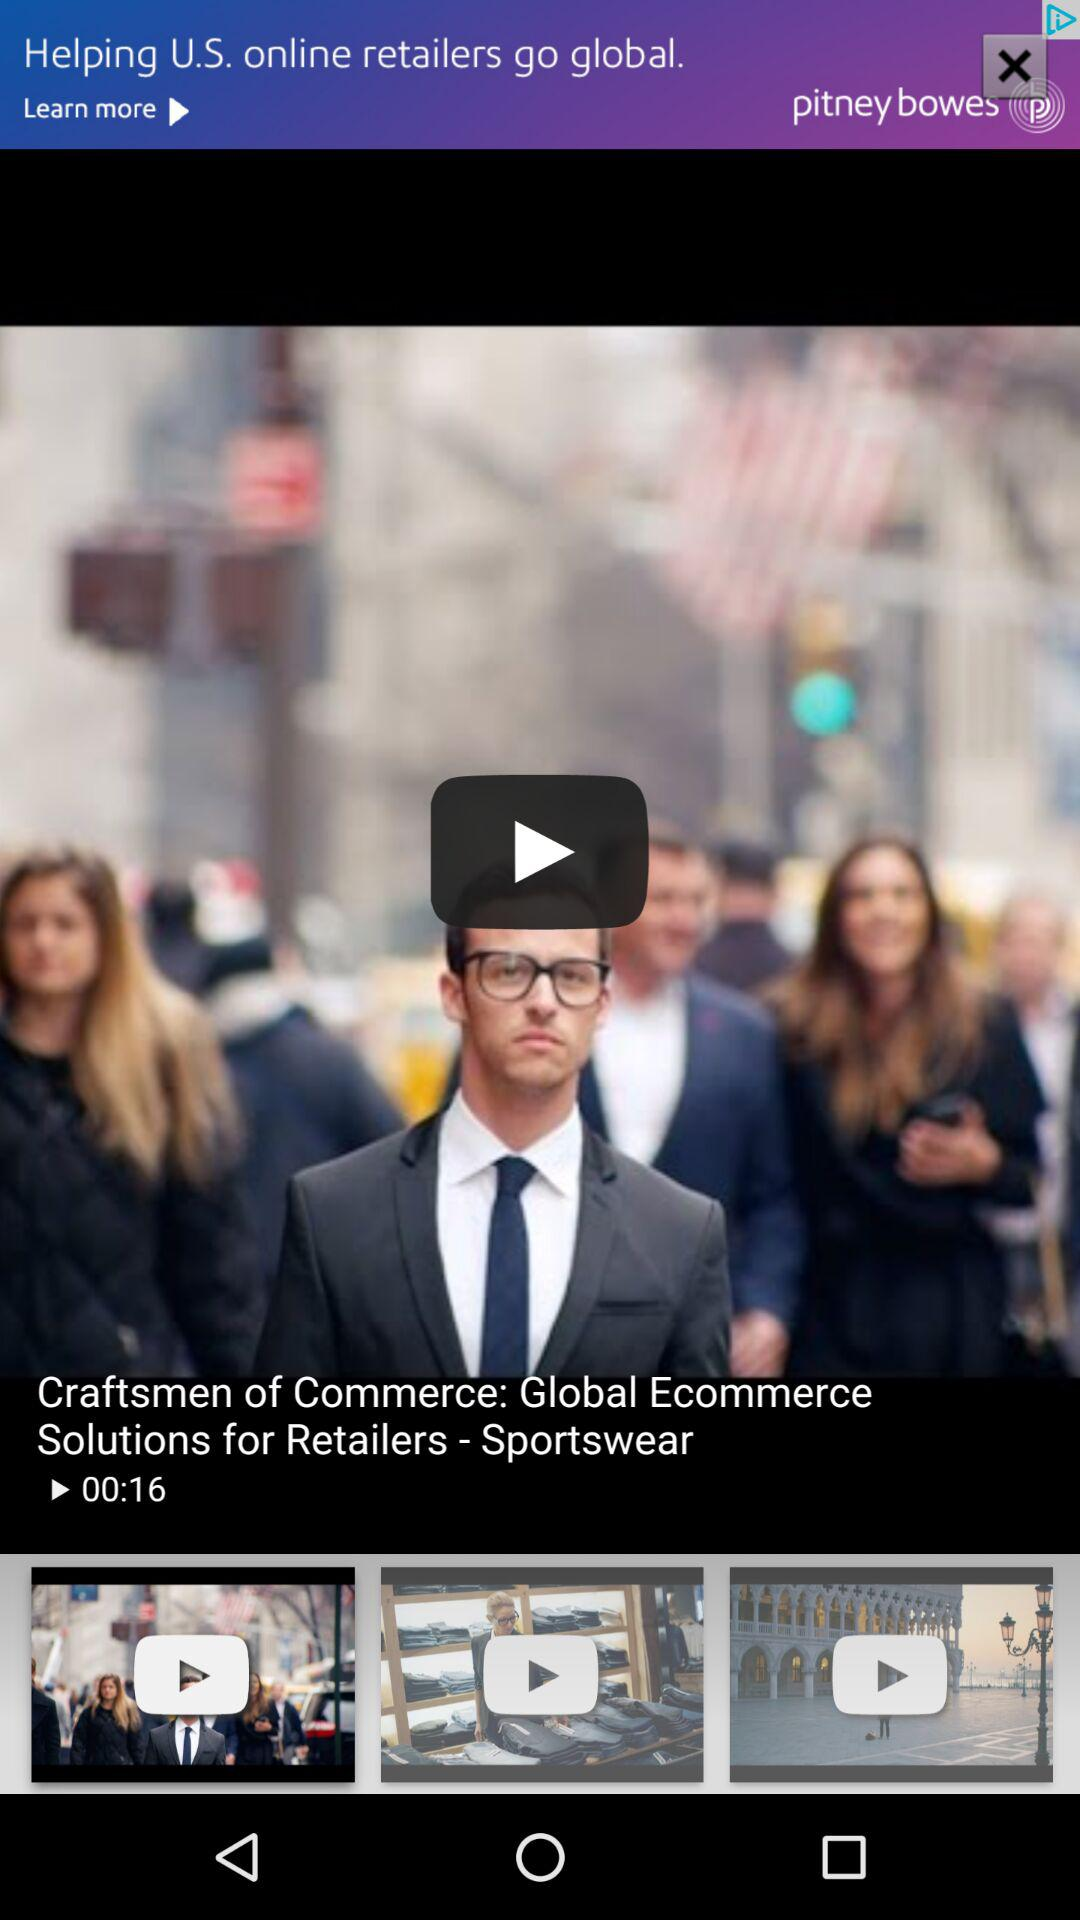What is the duration of the video "Craftsmen of Commerce"? The duration of the video "Craftsmen of Commerce" is 16 seconds. 